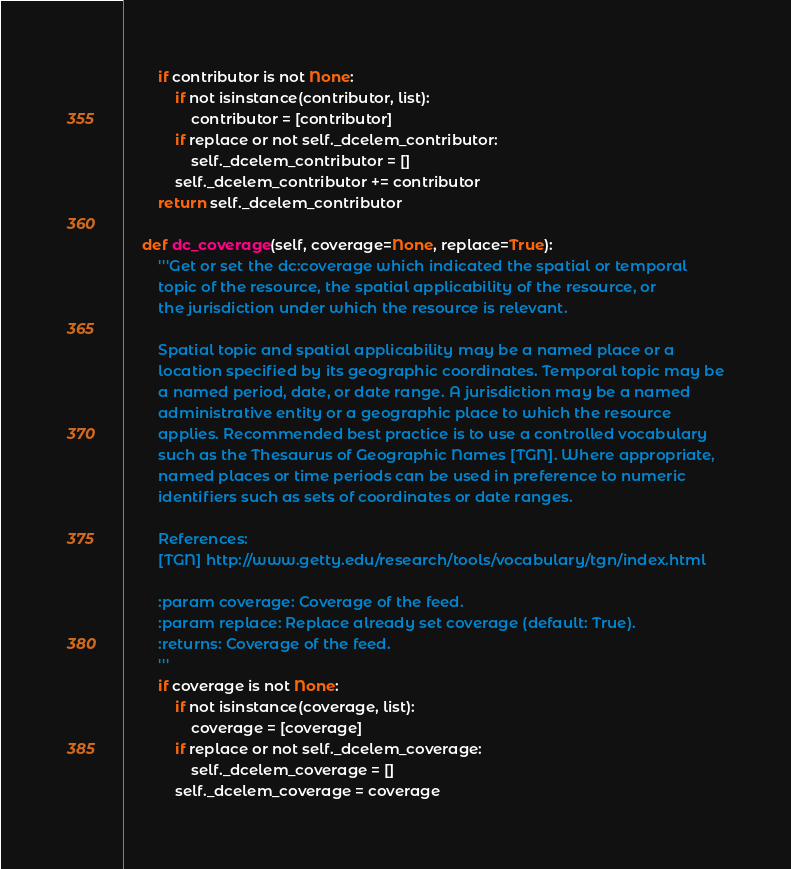<code> <loc_0><loc_0><loc_500><loc_500><_Python_>        if contributor is not None:
            if not isinstance(contributor, list):
                contributor = [contributor]
            if replace or not self._dcelem_contributor:
                self._dcelem_contributor = []
            self._dcelem_contributor += contributor
        return self._dcelem_contributor

    def dc_coverage(self, coverage=None, replace=True):
        '''Get or set the dc:coverage which indicated the spatial or temporal
        topic of the resource, the spatial applicability of the resource, or
        the jurisdiction under which the resource is relevant.

        Spatial topic and spatial applicability may be a named place or a
        location specified by its geographic coordinates. Temporal topic may be
        a named period, date, or date range. A jurisdiction may be a named
        administrative entity or a geographic place to which the resource
        applies. Recommended best practice is to use a controlled vocabulary
        such as the Thesaurus of Geographic Names [TGN]. Where appropriate,
        named places or time periods can be used in preference to numeric
        identifiers such as sets of coordinates or date ranges.

        References:
        [TGN] http://www.getty.edu/research/tools/vocabulary/tgn/index.html

        :param coverage: Coverage of the feed.
        :param replace: Replace already set coverage (default: True).
        :returns: Coverage of the feed.
        '''
        if coverage is not None:
            if not isinstance(coverage, list):
                coverage = [coverage]
            if replace or not self._dcelem_coverage:
                self._dcelem_coverage = []
            self._dcelem_coverage = coverage</code> 